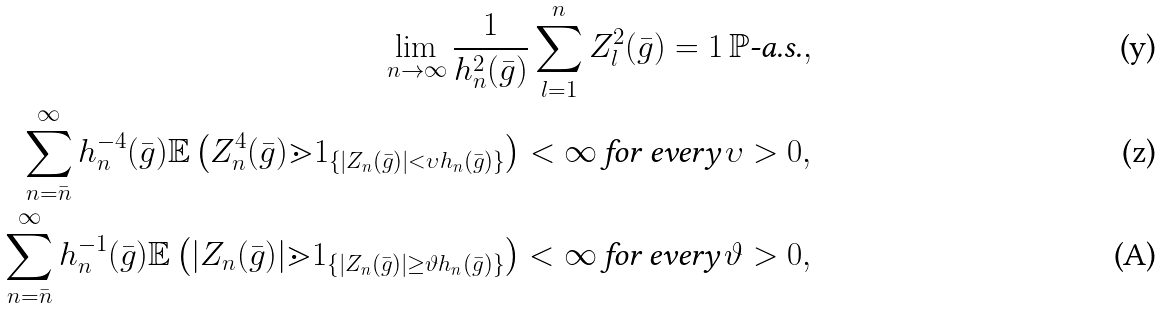<formula> <loc_0><loc_0><loc_500><loc_500>\lim _ { n \to \infty } \frac { 1 } { h _ { n } ^ { 2 } ( \bar { g } ) } \sum _ { l = 1 } ^ { n } Z _ { l } ^ { 2 } ( \bar { g } ) = 1 \, \mathbb { P } \text {-a.s.} , \\ \sum _ { n = \bar { n } } ^ { \infty } h _ { n } ^ { - 4 } ( \bar { g } ) \mathbb { E } \left ( Z _ { n } ^ { 4 } ( \bar { g } ) \mathbb { m } { 1 } _ { \left \{ | Z _ { n } ( \bar { g } ) | < \upsilon h _ { n } ( \bar { g } ) \right \} } \right ) < \infty \, \text {for every} \, \upsilon > 0 , \\ \sum _ { n = \bar { n } } ^ { \infty } h _ { n } ^ { - 1 } ( \bar { g } ) \mathbb { E } \left ( | Z _ { n } ( \bar { g } ) | \mathbb { m } { 1 } _ { \left \{ | Z _ { n } ( \bar { g } ) | \geq \vartheta h _ { n } ( \bar { g } ) \right \} } \right ) < \infty \, \text {for every} \, \vartheta > 0 ,</formula> 